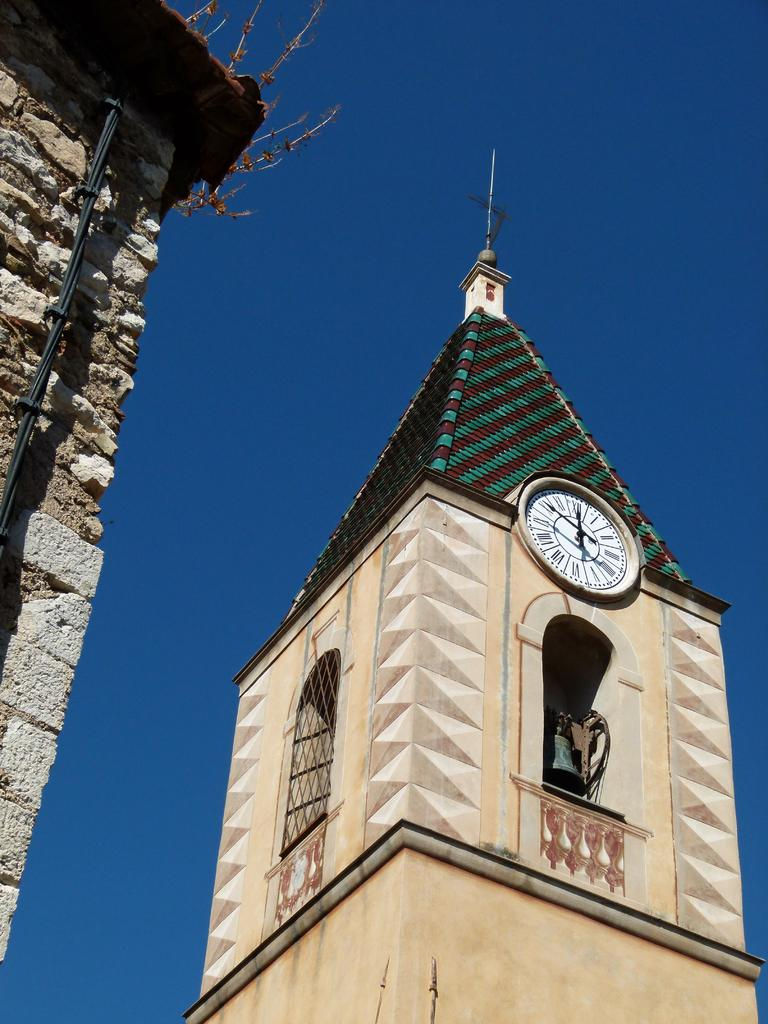What type of location is shown in the image? The image depicts a construction site. What object can be seen in the image that is typically used for measuring time? There is a clock in the image. What is visible at the top of the image? The sky is visible at the top of the image. How many nuts are being used as construction materials in the image? There are no nuts visible in the image; it depicts a construction site with traditional construction materials. What type of holiday is being celebrated at the construction site in the image? There is no indication of a holiday being celebrated in the image; it simply shows a construction site with a clock and visible sky. 